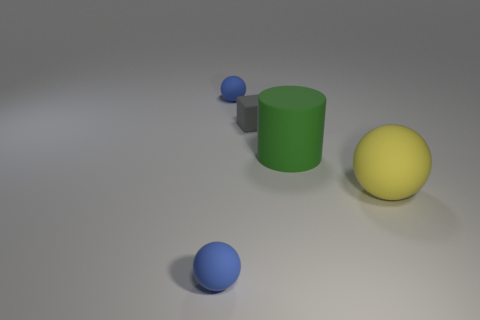Subtract all red cubes. How many blue balls are left? 2 Subtract 1 spheres. How many spheres are left? 2 Add 2 big cyan cubes. How many objects exist? 7 Subtract all blocks. How many objects are left? 4 Subtract 0 red blocks. How many objects are left? 5 Subtract all tiny cubes. Subtract all large green cylinders. How many objects are left? 3 Add 2 green objects. How many green objects are left? 3 Add 5 large blue shiny cubes. How many large blue shiny cubes exist? 5 